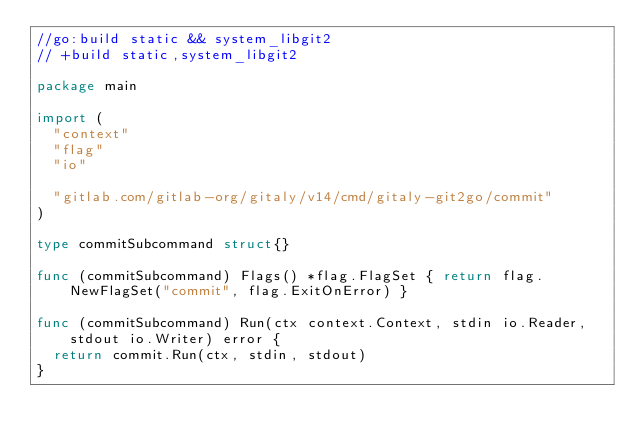Convert code to text. <code><loc_0><loc_0><loc_500><loc_500><_Go_>//go:build static && system_libgit2
// +build static,system_libgit2

package main

import (
	"context"
	"flag"
	"io"

	"gitlab.com/gitlab-org/gitaly/v14/cmd/gitaly-git2go/commit"
)

type commitSubcommand struct{}

func (commitSubcommand) Flags() *flag.FlagSet { return flag.NewFlagSet("commit", flag.ExitOnError) }

func (commitSubcommand) Run(ctx context.Context, stdin io.Reader, stdout io.Writer) error {
	return commit.Run(ctx, stdin, stdout)
}
</code> 